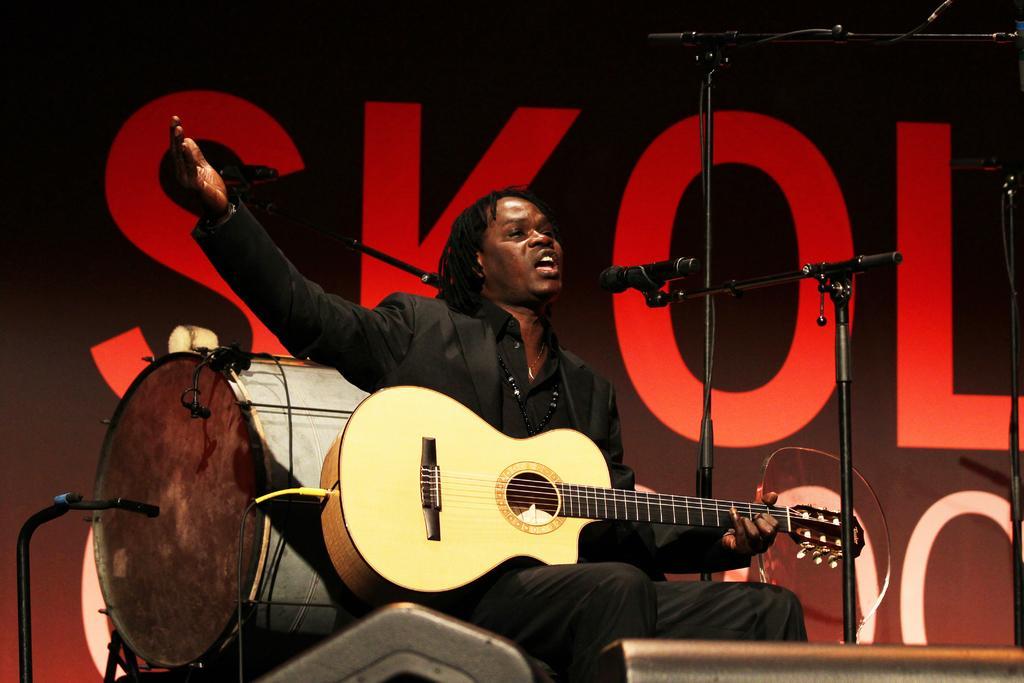How would you summarize this image in a sentence or two? In the middle of the image a man sitting and holding guitar and singing on the microphone. Behind him there is a drum. At the top of the image there is a banner. 